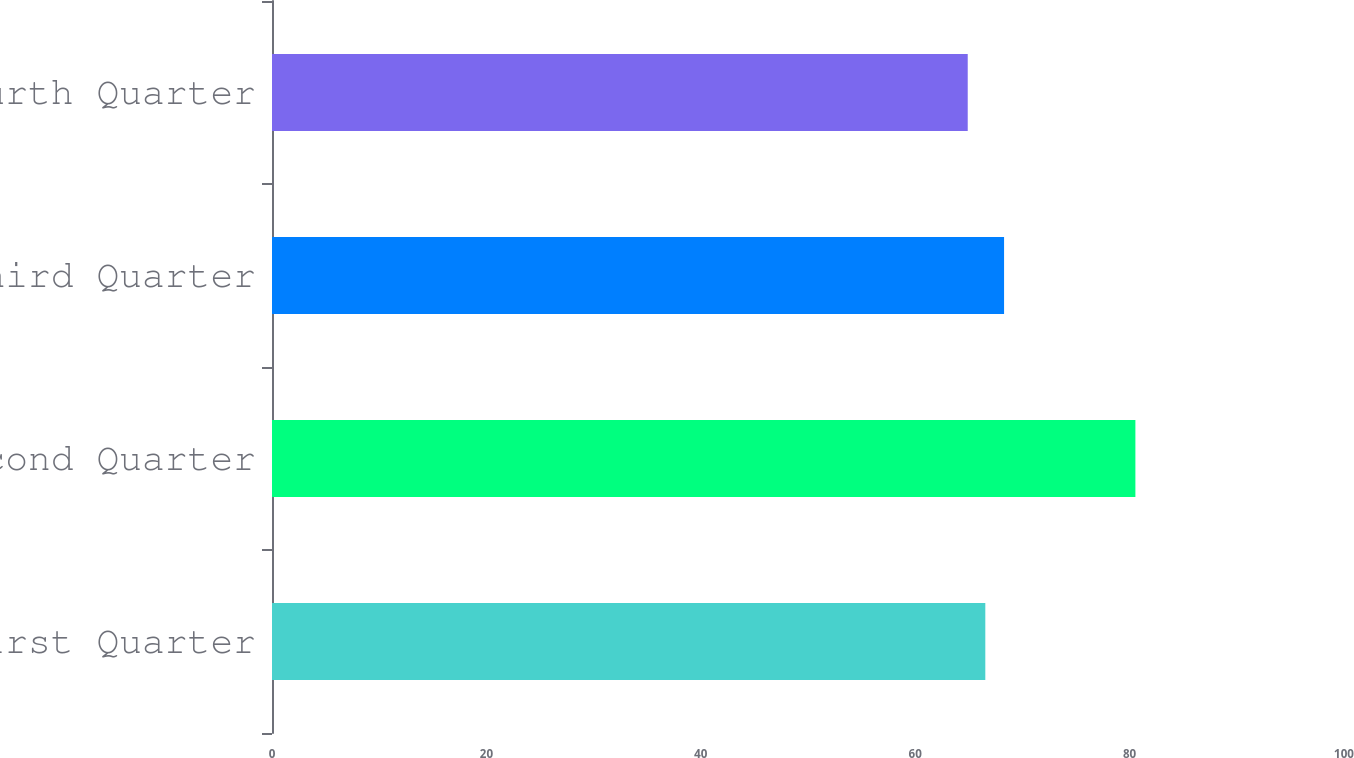Convert chart to OTSL. <chart><loc_0><loc_0><loc_500><loc_500><bar_chart><fcel>First Quarter<fcel>Second Quarter<fcel>Third Quarter<fcel>Fourth Quarter<nl><fcel>66.54<fcel>80.54<fcel>68.29<fcel>64.9<nl></chart> 